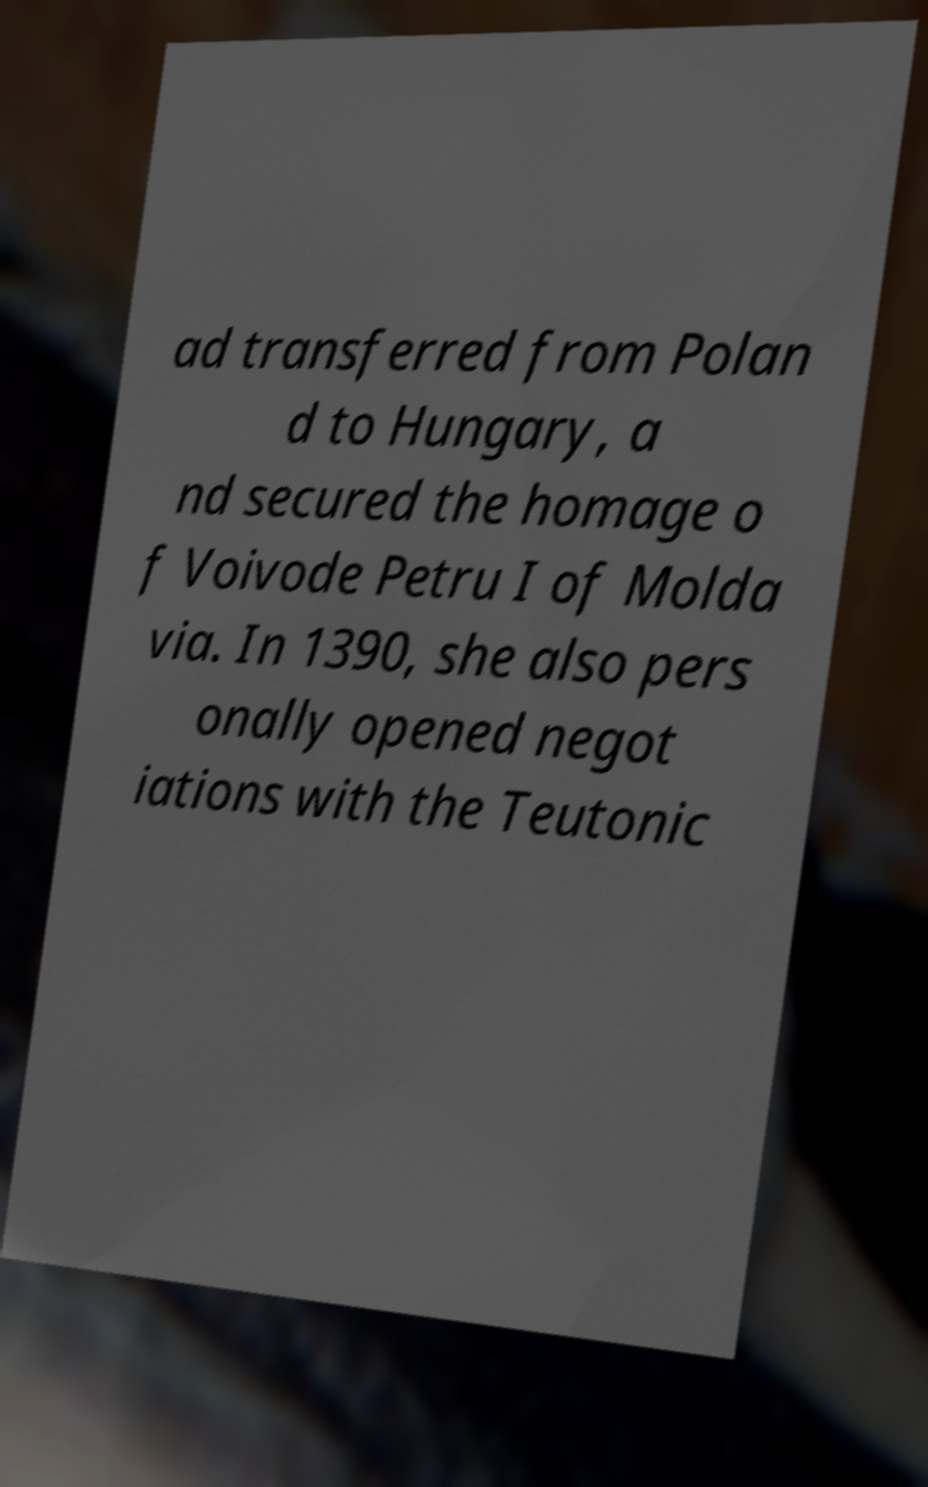Could you extract and type out the text from this image? ad transferred from Polan d to Hungary, a nd secured the homage o f Voivode Petru I of Molda via. In 1390, she also pers onally opened negot iations with the Teutonic 